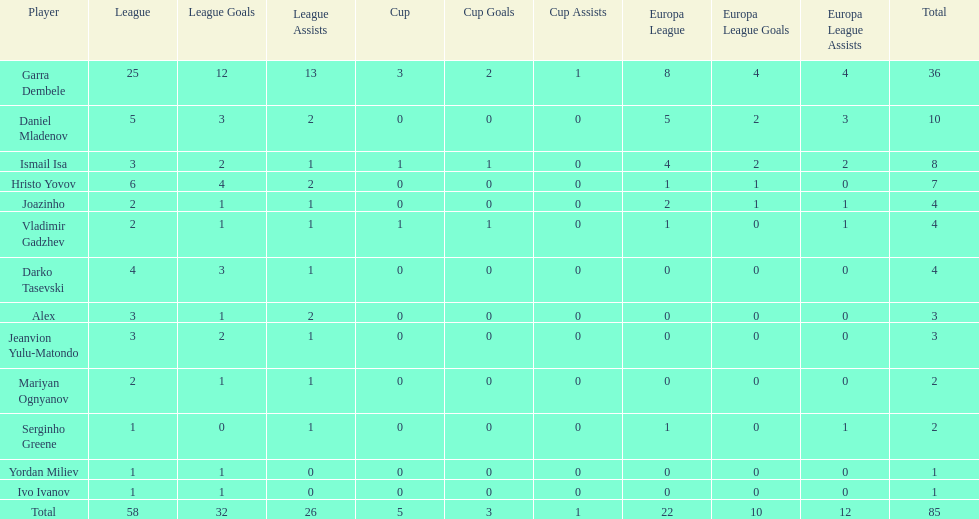How many participants achieved a total score of 4? 3. 